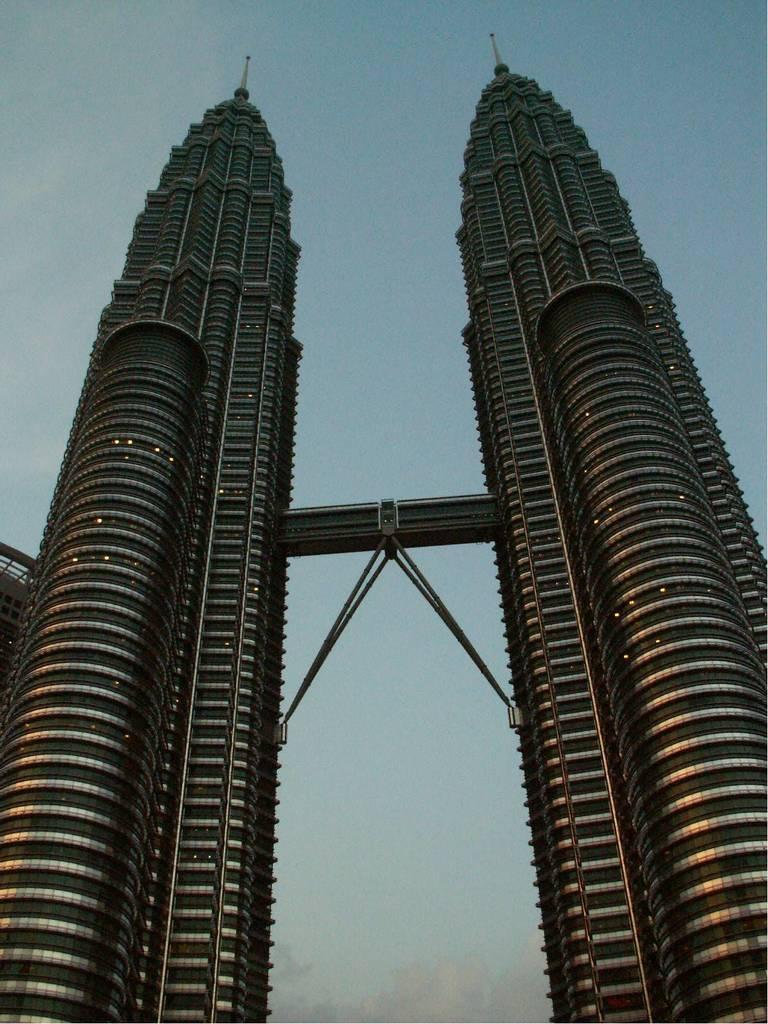Could you give a brief overview of what you see in this image? There are two tower buildings as we can see in the middle of this image, and there is a sky in the background. 